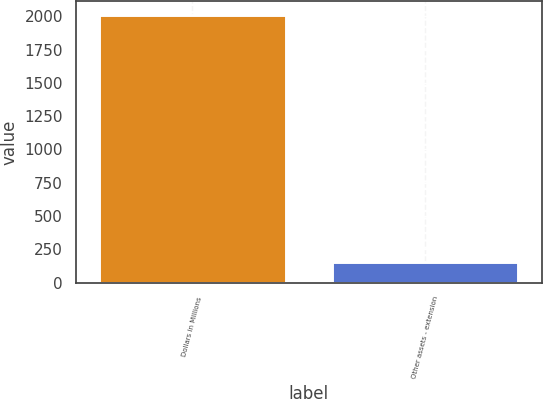Convert chart. <chart><loc_0><loc_0><loc_500><loc_500><bar_chart><fcel>Dollars in Millions<fcel>Other assets - extension<nl><fcel>2012<fcel>153<nl></chart> 